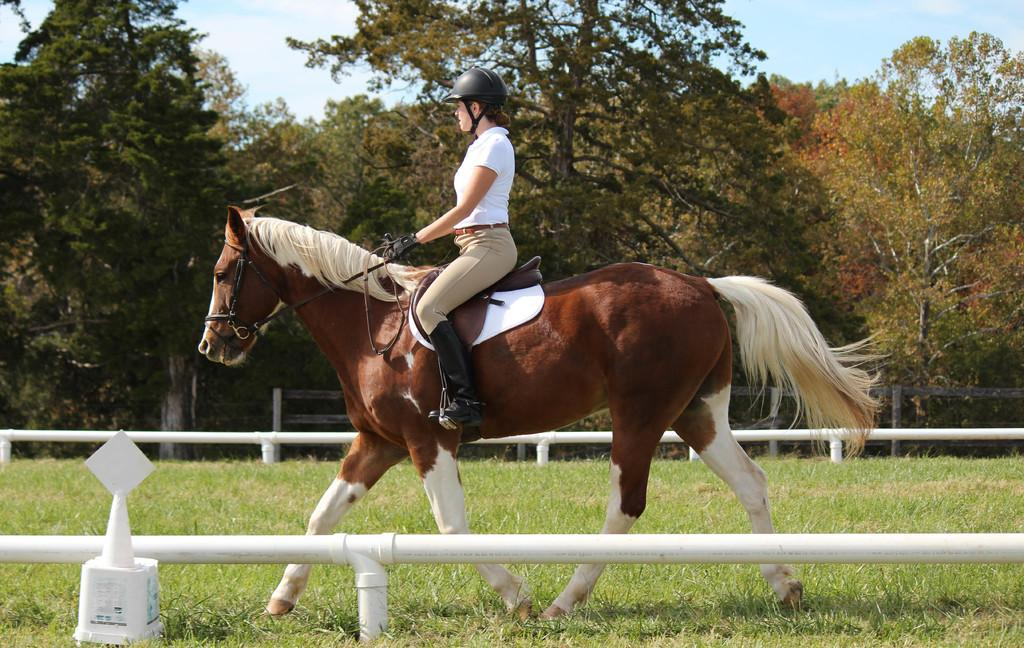Who is the main subject in the image? There is a woman in the image. What is the woman doing in the image? The woman is riding a horse. What protective gear is the woman wearing? The woman is wearing a helmet. What type of clothing is the woman wearing on her upper body? The woman is wearing a white T-shirt. What can be seen in the background of the image? There are trees and the sky visible in the background of the image. What type of oil is being used to lubricate the horse's legs in the image? There is no mention of oil or any lubrication being applied to the horse's legs in the image. 